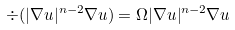<formula> <loc_0><loc_0><loc_500><loc_500>\div ( | \nabla u | ^ { n - 2 } \nabla u ) = \Omega | \nabla u | ^ { n - 2 } \nabla u</formula> 